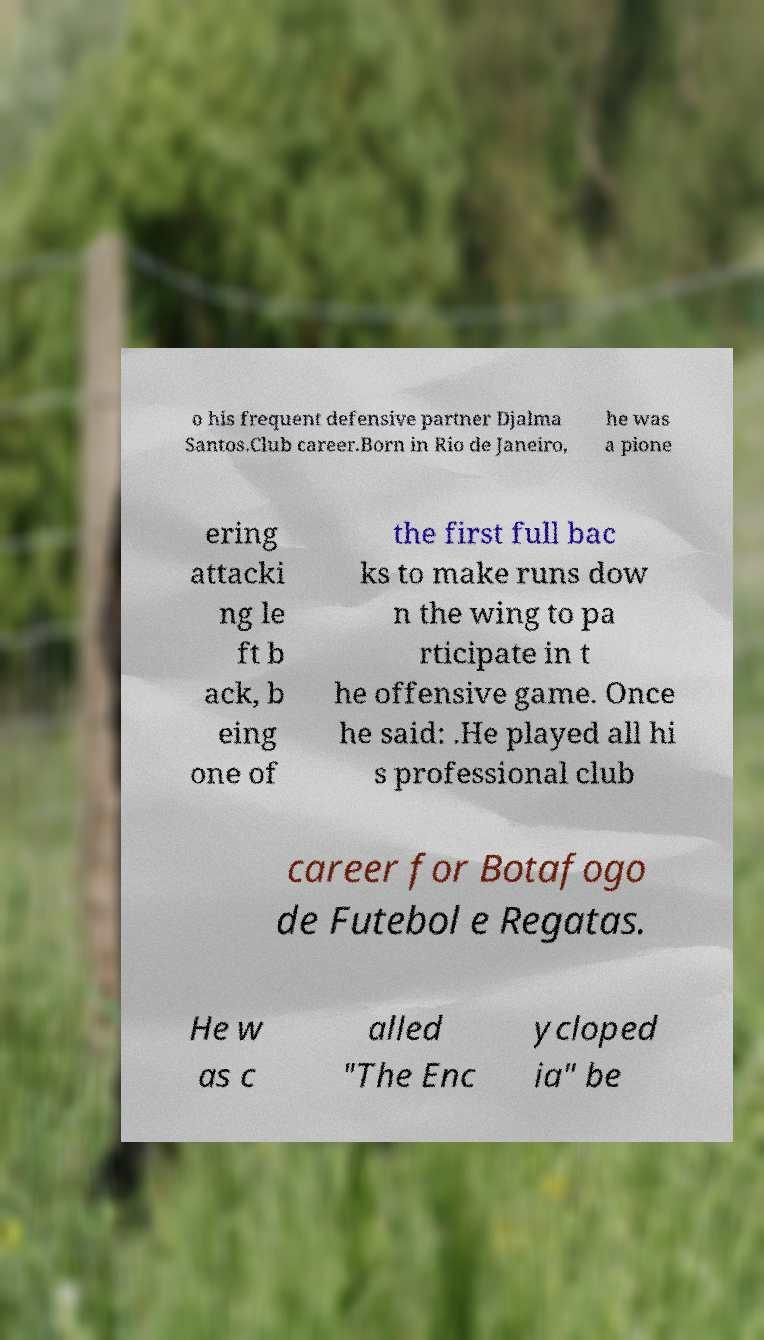What messages or text are displayed in this image? I need them in a readable, typed format. o his frequent defensive partner Djalma Santos.Club career.Born in Rio de Janeiro, he was a pione ering attacki ng le ft b ack, b eing one of the first full bac ks to make runs dow n the wing to pa rticipate in t he offensive game. Once he said: .He played all hi s professional club career for Botafogo de Futebol e Regatas. He w as c alled "The Enc ycloped ia" be 